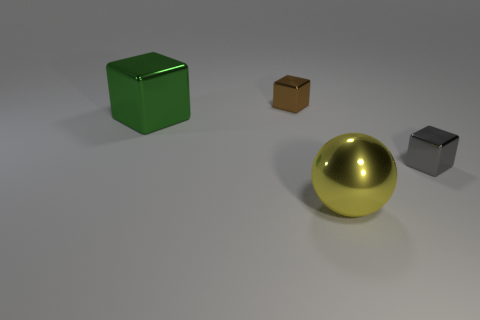Are there any gray blocks that have the same size as the green metallic cube?
Make the answer very short. No. Do the brown object and the big shiny thing that is left of the big yellow metal thing have the same shape?
Your answer should be compact. Yes. Do the object in front of the gray metal thing and the thing that is to the right of the ball have the same size?
Offer a very short reply. No. How many other things are there of the same shape as the yellow object?
Keep it short and to the point. 0. There is a small cube that is right of the object behind the large green shiny block; what is its material?
Ensure brevity in your answer.  Metal. What number of rubber objects are green things or large spheres?
Ensure brevity in your answer.  0. Are there any other things that are made of the same material as the tiny brown block?
Give a very brief answer. Yes. Is there a tiny metallic cube in front of the object to the right of the yellow ball?
Your response must be concise. No. What number of things are either small things that are in front of the large metallic block or tiny metallic cubes in front of the green thing?
Offer a terse response. 1. Is there anything else of the same color as the large ball?
Offer a very short reply. No. 